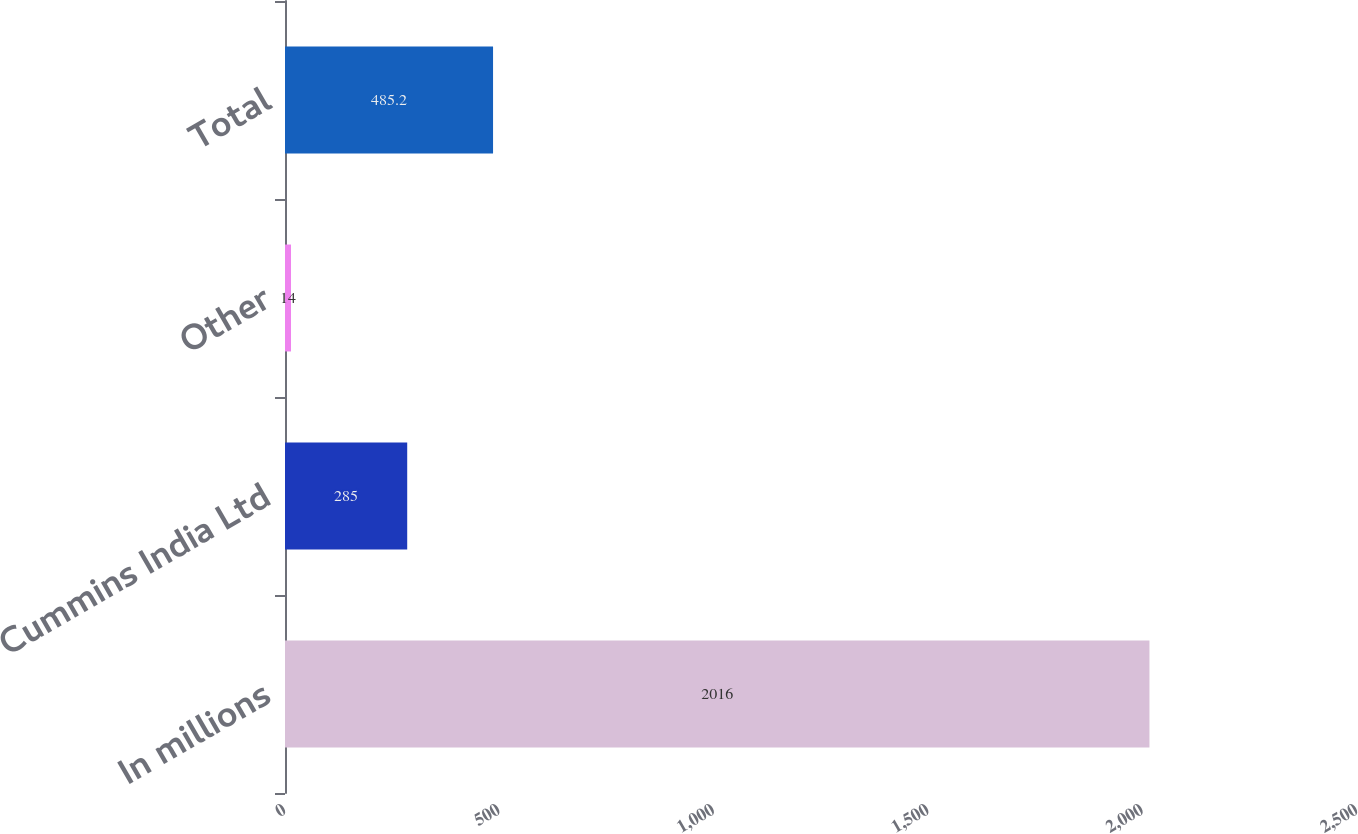Convert chart. <chart><loc_0><loc_0><loc_500><loc_500><bar_chart><fcel>In millions<fcel>Cummins India Ltd<fcel>Other<fcel>Total<nl><fcel>2016<fcel>285<fcel>14<fcel>485.2<nl></chart> 